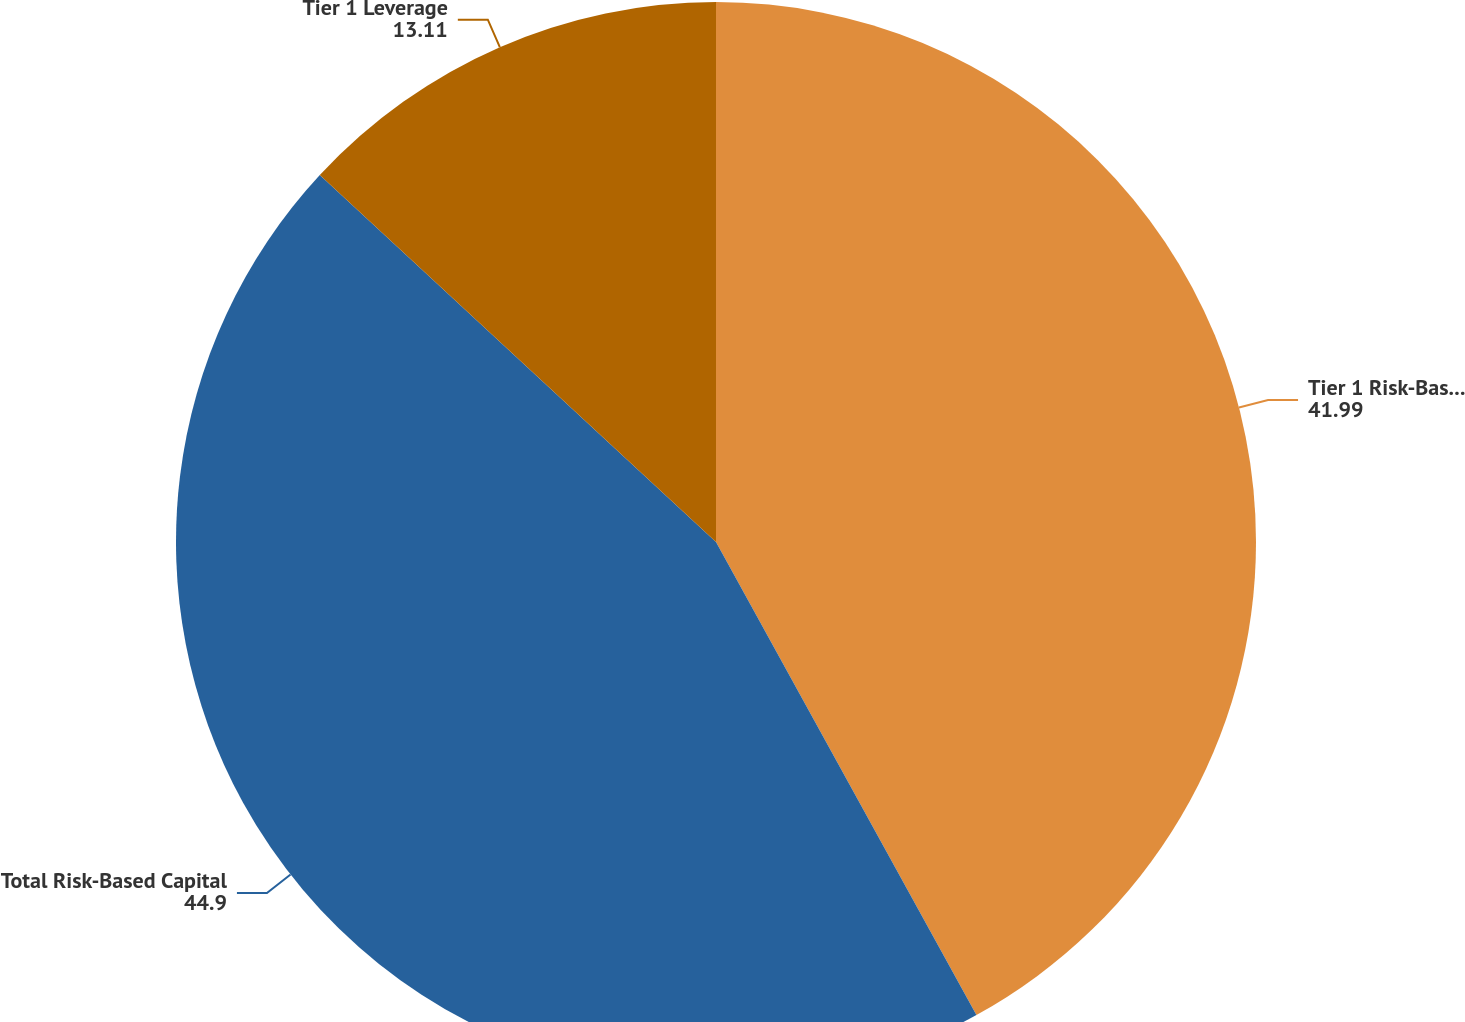Convert chart to OTSL. <chart><loc_0><loc_0><loc_500><loc_500><pie_chart><fcel>Tier 1 Risk-Based Capital<fcel>Total Risk-Based Capital<fcel>Tier 1 Leverage<nl><fcel>41.99%<fcel>44.9%<fcel>13.11%<nl></chart> 